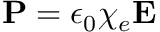Convert formula to latex. <formula><loc_0><loc_0><loc_500><loc_500>P = \epsilon _ { 0 } \chi _ { e } E</formula> 